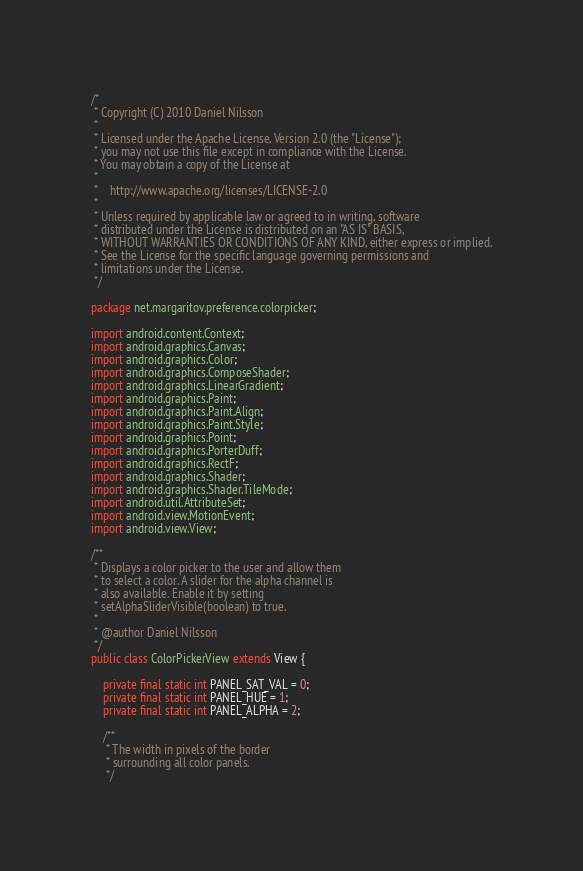Convert code to text. <code><loc_0><loc_0><loc_500><loc_500><_Java_>/*
 * Copyright (C) 2010 Daniel Nilsson
 *
 * Licensed under the Apache License, Version 2.0 (the "License");
 * you may not use this file except in compliance with the License.
 * You may obtain a copy of the License at
 *
 *	  http://www.apache.org/licenses/LICENSE-2.0
 *
 * Unless required by applicable law or agreed to in writing, software
 * distributed under the License is distributed on an "AS IS" BASIS,
 * WITHOUT WARRANTIES OR CONDITIONS OF ANY KIND, either express or implied.
 * See the License for the specific language governing permissions and
 * limitations under the License.
 */

package net.margaritov.preference.colorpicker;

import android.content.Context;
import android.graphics.Canvas;
import android.graphics.Color;
import android.graphics.ComposeShader;
import android.graphics.LinearGradient;
import android.graphics.Paint;
import android.graphics.Paint.Align;
import android.graphics.Paint.Style;
import android.graphics.Point;
import android.graphics.PorterDuff;
import android.graphics.RectF;
import android.graphics.Shader;
import android.graphics.Shader.TileMode;
import android.util.AttributeSet;
import android.view.MotionEvent;
import android.view.View;

/**
 * Displays a color picker to the user and allow them
 * to select a color. A slider for the alpha channel is
 * also available. Enable it by setting
 * setAlphaSliderVisible(boolean) to true.
 *
 * @author Daniel Nilsson
 */
public class ColorPickerView extends View {

	private final static int PANEL_SAT_VAL = 0;
	private final static int PANEL_HUE = 1;
	private final static int PANEL_ALPHA = 2;

	/**
	 * The width in pixels of the border
	 * surrounding all color panels.
	 */</code> 